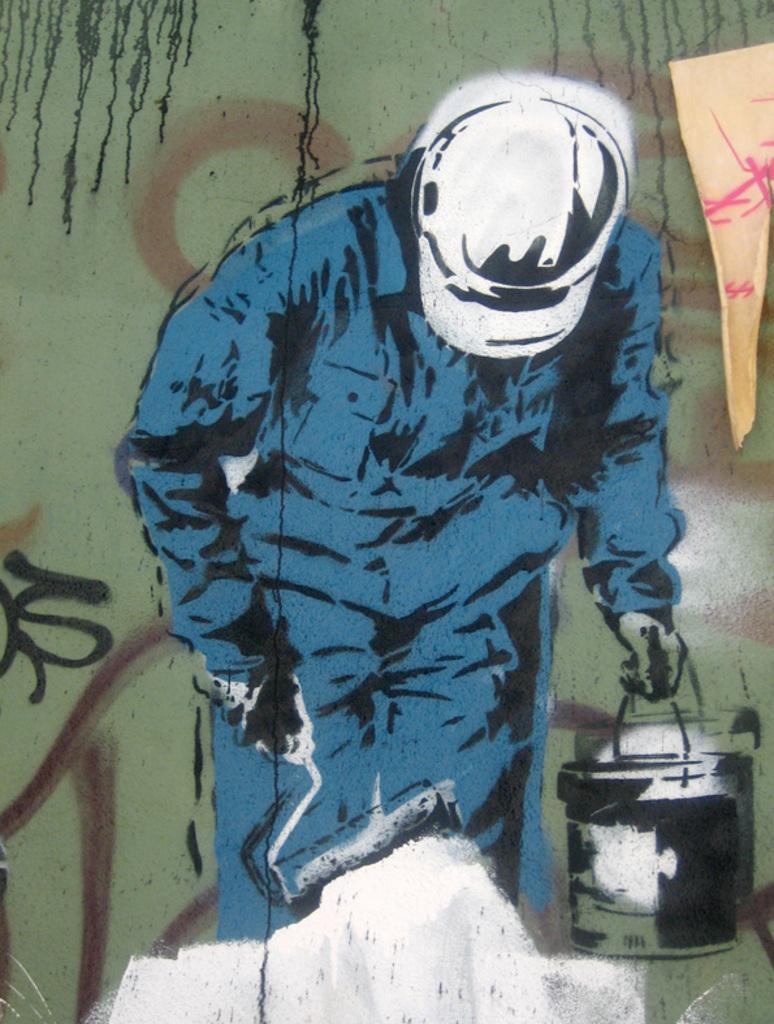Please provide a concise description of this image. There is a painting in which, there is a person wearing a white color helmet, holding a paint roller with one hand and painting on an object, and paint tin with the other hand and standing. In the background, there is a wall. 